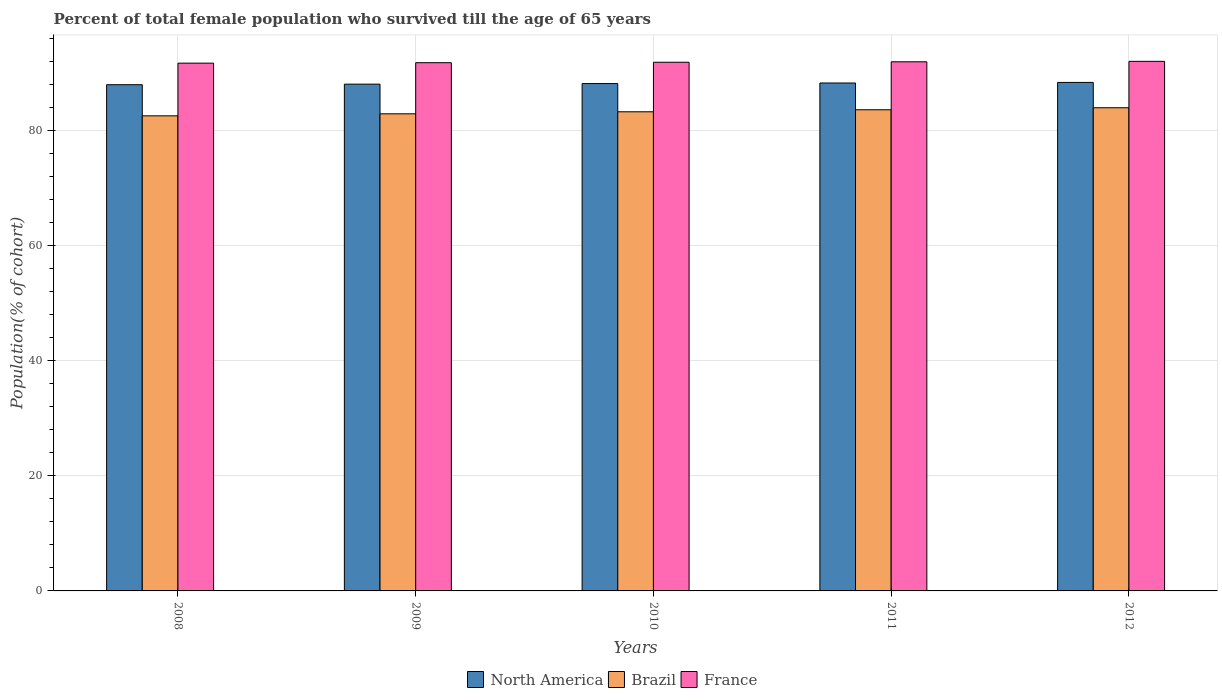How many groups of bars are there?
Provide a short and direct response. 5. Are the number of bars per tick equal to the number of legend labels?
Your answer should be very brief. Yes. Are the number of bars on each tick of the X-axis equal?
Provide a short and direct response. Yes. How many bars are there on the 1st tick from the right?
Make the answer very short. 3. What is the label of the 3rd group of bars from the left?
Give a very brief answer. 2010. In how many cases, is the number of bars for a given year not equal to the number of legend labels?
Offer a very short reply. 0. What is the percentage of total female population who survived till the age of 65 years in North America in 2009?
Offer a terse response. 88.02. Across all years, what is the maximum percentage of total female population who survived till the age of 65 years in Brazil?
Ensure brevity in your answer.  83.92. Across all years, what is the minimum percentage of total female population who survived till the age of 65 years in North America?
Your answer should be compact. 87.92. In which year was the percentage of total female population who survived till the age of 65 years in France minimum?
Ensure brevity in your answer.  2008. What is the total percentage of total female population who survived till the age of 65 years in Brazil in the graph?
Provide a succinct answer. 416.08. What is the difference between the percentage of total female population who survived till the age of 65 years in France in 2008 and that in 2010?
Your answer should be compact. -0.16. What is the difference between the percentage of total female population who survived till the age of 65 years in Brazil in 2008 and the percentage of total female population who survived till the age of 65 years in France in 2010?
Your response must be concise. -9.31. What is the average percentage of total female population who survived till the age of 65 years in North America per year?
Ensure brevity in your answer.  88.12. In the year 2011, what is the difference between the percentage of total female population who survived till the age of 65 years in France and percentage of total female population who survived till the age of 65 years in Brazil?
Your answer should be compact. 8.33. In how many years, is the percentage of total female population who survived till the age of 65 years in France greater than 72 %?
Keep it short and to the point. 5. What is the ratio of the percentage of total female population who survived till the age of 65 years in North America in 2010 to that in 2012?
Make the answer very short. 1. Is the percentage of total female population who survived till the age of 65 years in Brazil in 2008 less than that in 2009?
Provide a short and direct response. Yes. What is the difference between the highest and the second highest percentage of total female population who survived till the age of 65 years in North America?
Your answer should be very brief. 0.1. What is the difference between the highest and the lowest percentage of total female population who survived till the age of 65 years in Brazil?
Offer a terse response. 1.4. What does the 1st bar from the right in 2012 represents?
Your answer should be very brief. France. Is it the case that in every year, the sum of the percentage of total female population who survived till the age of 65 years in North America and percentage of total female population who survived till the age of 65 years in France is greater than the percentage of total female population who survived till the age of 65 years in Brazil?
Your response must be concise. Yes. How many bars are there?
Your answer should be very brief. 15. Does the graph contain grids?
Make the answer very short. Yes. What is the title of the graph?
Provide a short and direct response. Percent of total female population who survived till the age of 65 years. What is the label or title of the X-axis?
Your answer should be very brief. Years. What is the label or title of the Y-axis?
Ensure brevity in your answer.  Population(% of cohort). What is the Population(% of cohort) of North America in 2008?
Give a very brief answer. 87.92. What is the Population(% of cohort) in Brazil in 2008?
Provide a succinct answer. 82.51. What is the Population(% of cohort) of France in 2008?
Offer a very short reply. 91.67. What is the Population(% of cohort) of North America in 2009?
Provide a short and direct response. 88.02. What is the Population(% of cohort) of Brazil in 2009?
Offer a terse response. 82.87. What is the Population(% of cohort) of France in 2009?
Keep it short and to the point. 91.74. What is the Population(% of cohort) of North America in 2010?
Keep it short and to the point. 88.12. What is the Population(% of cohort) in Brazil in 2010?
Offer a very short reply. 83.22. What is the Population(% of cohort) in France in 2010?
Your answer should be very brief. 91.82. What is the Population(% of cohort) of North America in 2011?
Offer a very short reply. 88.22. What is the Population(% of cohort) of Brazil in 2011?
Provide a succinct answer. 83.57. What is the Population(% of cohort) in France in 2011?
Ensure brevity in your answer.  91.9. What is the Population(% of cohort) in North America in 2012?
Ensure brevity in your answer.  88.32. What is the Population(% of cohort) of Brazil in 2012?
Provide a succinct answer. 83.92. What is the Population(% of cohort) of France in 2012?
Ensure brevity in your answer.  91.98. Across all years, what is the maximum Population(% of cohort) of North America?
Keep it short and to the point. 88.32. Across all years, what is the maximum Population(% of cohort) of Brazil?
Offer a terse response. 83.92. Across all years, what is the maximum Population(% of cohort) in France?
Offer a terse response. 91.98. Across all years, what is the minimum Population(% of cohort) in North America?
Make the answer very short. 87.92. Across all years, what is the minimum Population(% of cohort) in Brazil?
Your answer should be compact. 82.51. Across all years, what is the minimum Population(% of cohort) of France?
Provide a short and direct response. 91.67. What is the total Population(% of cohort) of North America in the graph?
Ensure brevity in your answer.  440.59. What is the total Population(% of cohort) in Brazil in the graph?
Provide a short and direct response. 416.08. What is the total Population(% of cohort) of France in the graph?
Your answer should be compact. 459.11. What is the difference between the Population(% of cohort) of North America in 2008 and that in 2009?
Ensure brevity in your answer.  -0.1. What is the difference between the Population(% of cohort) in Brazil in 2008 and that in 2009?
Offer a very short reply. -0.35. What is the difference between the Population(% of cohort) in France in 2008 and that in 2009?
Offer a terse response. -0.08. What is the difference between the Population(% of cohort) in North America in 2008 and that in 2010?
Your answer should be compact. -0.2. What is the difference between the Population(% of cohort) in Brazil in 2008 and that in 2010?
Ensure brevity in your answer.  -0.7. What is the difference between the Population(% of cohort) in France in 2008 and that in 2010?
Make the answer very short. -0.16. What is the difference between the Population(% of cohort) in North America in 2008 and that in 2011?
Provide a succinct answer. -0.3. What is the difference between the Population(% of cohort) in Brazil in 2008 and that in 2011?
Your answer should be very brief. -1.05. What is the difference between the Population(% of cohort) in France in 2008 and that in 2011?
Your answer should be very brief. -0.23. What is the difference between the Population(% of cohort) of North America in 2008 and that in 2012?
Your answer should be very brief. -0.4. What is the difference between the Population(% of cohort) of Brazil in 2008 and that in 2012?
Offer a terse response. -1.4. What is the difference between the Population(% of cohort) in France in 2008 and that in 2012?
Your answer should be compact. -0.31. What is the difference between the Population(% of cohort) in North America in 2009 and that in 2010?
Keep it short and to the point. -0.1. What is the difference between the Population(% of cohort) in Brazil in 2009 and that in 2010?
Give a very brief answer. -0.35. What is the difference between the Population(% of cohort) of France in 2009 and that in 2010?
Keep it short and to the point. -0.08. What is the difference between the Population(% of cohort) in North America in 2009 and that in 2011?
Ensure brevity in your answer.  -0.2. What is the difference between the Population(% of cohort) in Brazil in 2009 and that in 2011?
Provide a succinct answer. -0.7. What is the difference between the Population(% of cohort) in France in 2009 and that in 2011?
Make the answer very short. -0.16. What is the difference between the Population(% of cohort) in North America in 2009 and that in 2012?
Provide a short and direct response. -0.3. What is the difference between the Population(% of cohort) in Brazil in 2009 and that in 2012?
Ensure brevity in your answer.  -1.05. What is the difference between the Population(% of cohort) of France in 2009 and that in 2012?
Your answer should be compact. -0.23. What is the difference between the Population(% of cohort) in North America in 2010 and that in 2011?
Offer a terse response. -0.1. What is the difference between the Population(% of cohort) of Brazil in 2010 and that in 2011?
Provide a short and direct response. -0.35. What is the difference between the Population(% of cohort) in France in 2010 and that in 2011?
Provide a short and direct response. -0.08. What is the difference between the Population(% of cohort) in North America in 2010 and that in 2012?
Keep it short and to the point. -0.2. What is the difference between the Population(% of cohort) of Brazil in 2010 and that in 2012?
Provide a short and direct response. -0.7. What is the difference between the Population(% of cohort) of France in 2010 and that in 2012?
Your answer should be very brief. -0.16. What is the difference between the Population(% of cohort) in North America in 2011 and that in 2012?
Provide a succinct answer. -0.1. What is the difference between the Population(% of cohort) of Brazil in 2011 and that in 2012?
Offer a terse response. -0.35. What is the difference between the Population(% of cohort) of France in 2011 and that in 2012?
Make the answer very short. -0.08. What is the difference between the Population(% of cohort) of North America in 2008 and the Population(% of cohort) of Brazil in 2009?
Provide a succinct answer. 5.05. What is the difference between the Population(% of cohort) of North America in 2008 and the Population(% of cohort) of France in 2009?
Your answer should be compact. -3.82. What is the difference between the Population(% of cohort) of Brazil in 2008 and the Population(% of cohort) of France in 2009?
Your answer should be very brief. -9.23. What is the difference between the Population(% of cohort) in North America in 2008 and the Population(% of cohort) in Brazil in 2010?
Your response must be concise. 4.7. What is the difference between the Population(% of cohort) in North America in 2008 and the Population(% of cohort) in France in 2010?
Your response must be concise. -3.9. What is the difference between the Population(% of cohort) in Brazil in 2008 and the Population(% of cohort) in France in 2010?
Ensure brevity in your answer.  -9.31. What is the difference between the Population(% of cohort) of North America in 2008 and the Population(% of cohort) of Brazil in 2011?
Provide a succinct answer. 4.35. What is the difference between the Population(% of cohort) of North America in 2008 and the Population(% of cohort) of France in 2011?
Provide a succinct answer. -3.98. What is the difference between the Population(% of cohort) in Brazil in 2008 and the Population(% of cohort) in France in 2011?
Offer a terse response. -9.38. What is the difference between the Population(% of cohort) of North America in 2008 and the Population(% of cohort) of Brazil in 2012?
Give a very brief answer. 4. What is the difference between the Population(% of cohort) in North America in 2008 and the Population(% of cohort) in France in 2012?
Your answer should be very brief. -4.06. What is the difference between the Population(% of cohort) in Brazil in 2008 and the Population(% of cohort) in France in 2012?
Keep it short and to the point. -9.46. What is the difference between the Population(% of cohort) of North America in 2009 and the Population(% of cohort) of Brazil in 2010?
Your answer should be very brief. 4.8. What is the difference between the Population(% of cohort) in North America in 2009 and the Population(% of cohort) in France in 2010?
Offer a terse response. -3.8. What is the difference between the Population(% of cohort) in Brazil in 2009 and the Population(% of cohort) in France in 2010?
Your response must be concise. -8.96. What is the difference between the Population(% of cohort) of North America in 2009 and the Population(% of cohort) of Brazil in 2011?
Give a very brief answer. 4.45. What is the difference between the Population(% of cohort) in North America in 2009 and the Population(% of cohort) in France in 2011?
Make the answer very short. -3.88. What is the difference between the Population(% of cohort) in Brazil in 2009 and the Population(% of cohort) in France in 2011?
Your answer should be compact. -9.03. What is the difference between the Population(% of cohort) in North America in 2009 and the Population(% of cohort) in Brazil in 2012?
Your answer should be very brief. 4.1. What is the difference between the Population(% of cohort) in North America in 2009 and the Population(% of cohort) in France in 2012?
Your answer should be very brief. -3.96. What is the difference between the Population(% of cohort) of Brazil in 2009 and the Population(% of cohort) of France in 2012?
Provide a short and direct response. -9.11. What is the difference between the Population(% of cohort) in North America in 2010 and the Population(% of cohort) in Brazil in 2011?
Provide a succinct answer. 4.55. What is the difference between the Population(% of cohort) in North America in 2010 and the Population(% of cohort) in France in 2011?
Ensure brevity in your answer.  -3.78. What is the difference between the Population(% of cohort) of Brazil in 2010 and the Population(% of cohort) of France in 2011?
Offer a terse response. -8.68. What is the difference between the Population(% of cohort) of North America in 2010 and the Population(% of cohort) of Brazil in 2012?
Your response must be concise. 4.2. What is the difference between the Population(% of cohort) of North America in 2010 and the Population(% of cohort) of France in 2012?
Make the answer very short. -3.86. What is the difference between the Population(% of cohort) in Brazil in 2010 and the Population(% of cohort) in France in 2012?
Make the answer very short. -8.76. What is the difference between the Population(% of cohort) in North America in 2011 and the Population(% of cohort) in Brazil in 2012?
Offer a very short reply. 4.3. What is the difference between the Population(% of cohort) of North America in 2011 and the Population(% of cohort) of France in 2012?
Provide a succinct answer. -3.76. What is the difference between the Population(% of cohort) of Brazil in 2011 and the Population(% of cohort) of France in 2012?
Offer a very short reply. -8.41. What is the average Population(% of cohort) in North America per year?
Your response must be concise. 88.12. What is the average Population(% of cohort) of Brazil per year?
Ensure brevity in your answer.  83.22. What is the average Population(% of cohort) in France per year?
Give a very brief answer. 91.82. In the year 2008, what is the difference between the Population(% of cohort) of North America and Population(% of cohort) of Brazil?
Provide a succinct answer. 5.4. In the year 2008, what is the difference between the Population(% of cohort) in North America and Population(% of cohort) in France?
Offer a terse response. -3.75. In the year 2008, what is the difference between the Population(% of cohort) in Brazil and Population(% of cohort) in France?
Your answer should be compact. -9.15. In the year 2009, what is the difference between the Population(% of cohort) in North America and Population(% of cohort) in Brazil?
Give a very brief answer. 5.15. In the year 2009, what is the difference between the Population(% of cohort) in North America and Population(% of cohort) in France?
Provide a succinct answer. -3.72. In the year 2009, what is the difference between the Population(% of cohort) in Brazil and Population(% of cohort) in France?
Make the answer very short. -8.88. In the year 2010, what is the difference between the Population(% of cohort) of North America and Population(% of cohort) of Brazil?
Offer a terse response. 4.9. In the year 2010, what is the difference between the Population(% of cohort) of North America and Population(% of cohort) of France?
Give a very brief answer. -3.7. In the year 2010, what is the difference between the Population(% of cohort) of Brazil and Population(% of cohort) of France?
Your answer should be very brief. -8.61. In the year 2011, what is the difference between the Population(% of cohort) of North America and Population(% of cohort) of Brazil?
Offer a very short reply. 4.65. In the year 2011, what is the difference between the Population(% of cohort) of North America and Population(% of cohort) of France?
Give a very brief answer. -3.68. In the year 2011, what is the difference between the Population(% of cohort) of Brazil and Population(% of cohort) of France?
Your answer should be very brief. -8.33. In the year 2012, what is the difference between the Population(% of cohort) in North America and Population(% of cohort) in Brazil?
Provide a succinct answer. 4.4. In the year 2012, what is the difference between the Population(% of cohort) of North America and Population(% of cohort) of France?
Provide a short and direct response. -3.66. In the year 2012, what is the difference between the Population(% of cohort) in Brazil and Population(% of cohort) in France?
Your answer should be compact. -8.06. What is the ratio of the Population(% of cohort) of France in 2008 to that in 2010?
Your answer should be very brief. 1. What is the ratio of the Population(% of cohort) of North America in 2008 to that in 2011?
Provide a short and direct response. 1. What is the ratio of the Population(% of cohort) of Brazil in 2008 to that in 2011?
Give a very brief answer. 0.99. What is the ratio of the Population(% of cohort) in France in 2008 to that in 2011?
Your answer should be compact. 1. What is the ratio of the Population(% of cohort) of Brazil in 2008 to that in 2012?
Keep it short and to the point. 0.98. What is the ratio of the Population(% of cohort) in France in 2008 to that in 2012?
Offer a terse response. 1. What is the ratio of the Population(% of cohort) of France in 2009 to that in 2011?
Ensure brevity in your answer.  1. What is the ratio of the Population(% of cohort) of North America in 2009 to that in 2012?
Provide a short and direct response. 1. What is the ratio of the Population(% of cohort) in Brazil in 2009 to that in 2012?
Give a very brief answer. 0.99. What is the ratio of the Population(% of cohort) of North America in 2010 to that in 2011?
Your response must be concise. 1. What is the ratio of the Population(% of cohort) of Brazil in 2010 to that in 2011?
Provide a succinct answer. 1. What is the ratio of the Population(% of cohort) in France in 2010 to that in 2011?
Make the answer very short. 1. What is the ratio of the Population(% of cohort) of North America in 2010 to that in 2012?
Give a very brief answer. 1. What is the ratio of the Population(% of cohort) of France in 2010 to that in 2012?
Offer a terse response. 1. What is the difference between the highest and the second highest Population(% of cohort) in North America?
Provide a short and direct response. 0.1. What is the difference between the highest and the second highest Population(% of cohort) in Brazil?
Keep it short and to the point. 0.35. What is the difference between the highest and the second highest Population(% of cohort) in France?
Keep it short and to the point. 0.08. What is the difference between the highest and the lowest Population(% of cohort) of North America?
Provide a short and direct response. 0.4. What is the difference between the highest and the lowest Population(% of cohort) of Brazil?
Give a very brief answer. 1.4. What is the difference between the highest and the lowest Population(% of cohort) of France?
Make the answer very short. 0.31. 